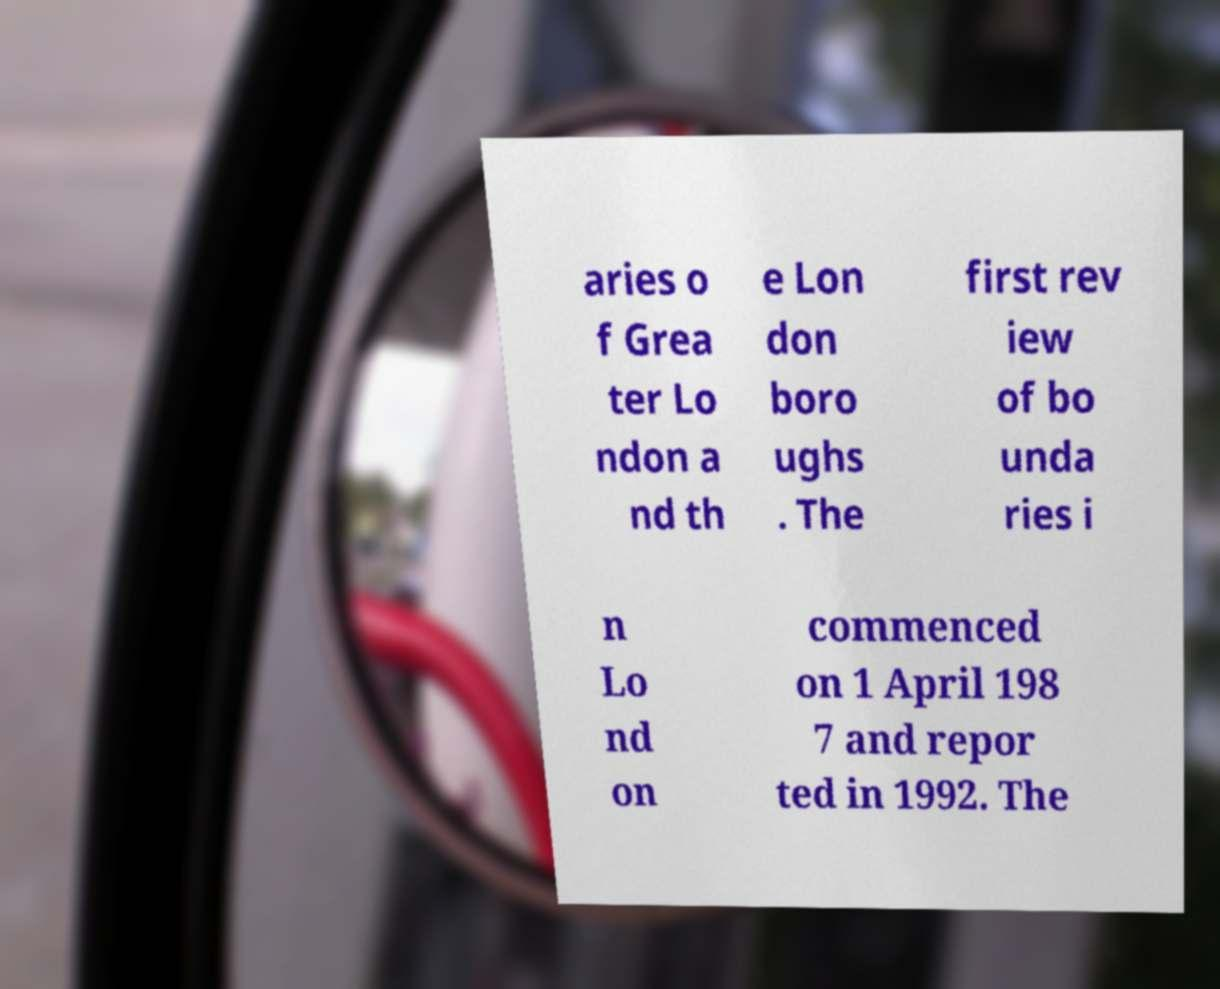Please identify and transcribe the text found in this image. aries o f Grea ter Lo ndon a nd th e Lon don boro ughs . The first rev iew of bo unda ries i n Lo nd on commenced on 1 April 198 7 and repor ted in 1992. The 